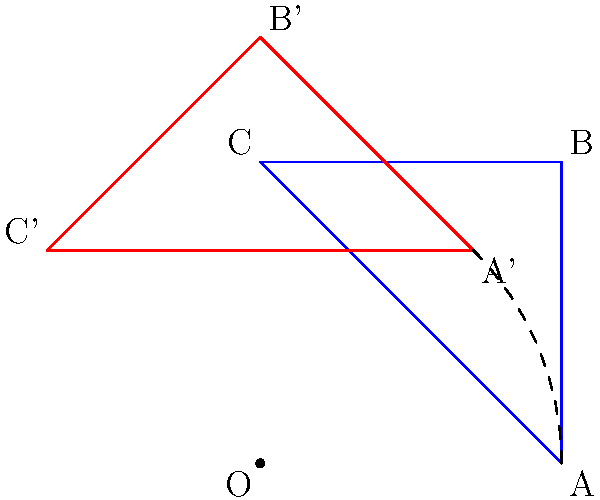In a Python application that processes geometric shapes, a triangle ABC is rotated 45 degrees counterclockwise around the origin O (0,0) to form triangle A'B'C'. How might this rotation operation potentially introduce security vulnerabilities in the code, and what specific security measure should be implemented to mitigate risks associated with user-supplied input for rotation angles? To understand the security implications of this geometric operation in Python code, let's break it down step-by-step:

1. The rotation operation involves trigonometric calculations, typically using functions like sine and cosine.

2. In Python, these calculations often use floating-point arithmetic, which can lead to precision issues.

3. User-supplied input for rotation angles (e.g., 45 degrees) needs to be carefully validated and sanitized.

4. Potential security vulnerabilities include:
   a) Integer overflow: If the angle is stored as an integer and can be manipulated by user input.
   b) Buffer overflow: If the input is not properly bounded and exceeds allocated memory.
   c) Floating-point vulnerabilities: Rounding errors or unexpected behavior with certain inputs.

5. A specific attack vector could be a carefully crafted input that exploits these vulnerabilities to cause unexpected behavior or crashes.

6. To mitigate these risks, input validation is crucial. This should include:
   a) Checking that the input is within a valid range (e.g., 0 to 360 degrees).
   b) Ensuring the input is of the expected type (float or integer).
   c) Sanitizing the input to prevent injection attacks.

7. Additionally, using secure math libraries that handle edge cases and potential overflows can help prevent vulnerabilities.

8. Implementing proper error handling and exception catching is also important to prevent information leakage or application crashes.

9. A specific security measure to implement is to use a decorator or wrapper function that validates and sanitizes the rotation angle input before it's used in any calculations.
Answer: Implement input validation and sanitization for rotation angles using a decorator function. 